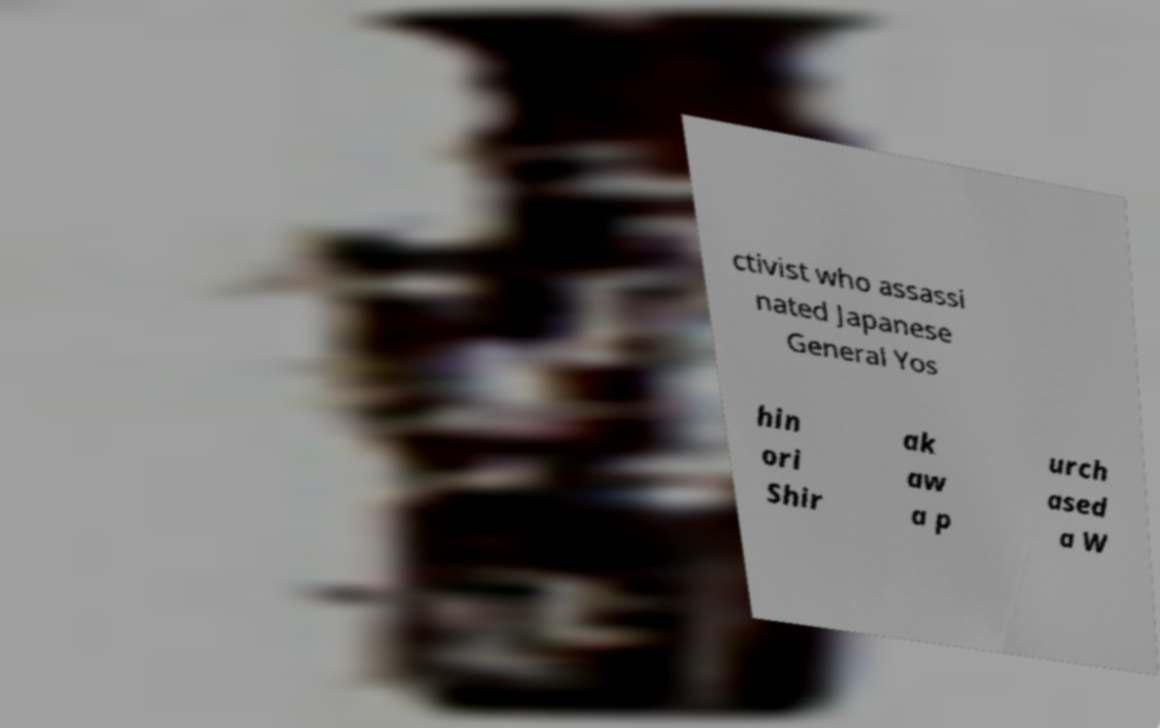Please read and relay the text visible in this image. What does it say? ctivist who assassi nated Japanese General Yos hin ori Shir ak aw a p urch ased a W 